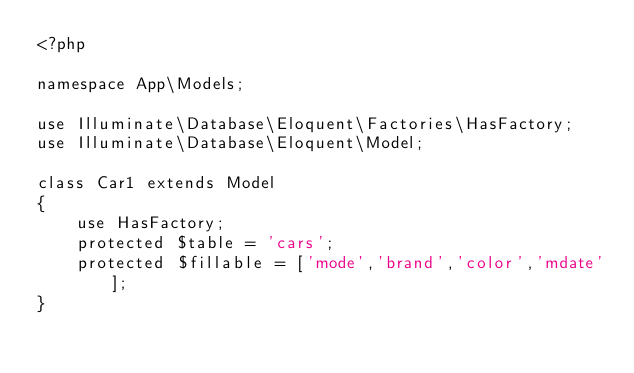<code> <loc_0><loc_0><loc_500><loc_500><_PHP_><?php

namespace App\Models;

use Illuminate\Database\Eloquent\Factories\HasFactory;
use Illuminate\Database\Eloquent\Model;

class Car1 extends Model
{
    use HasFactory;
    protected $table = 'cars';
    protected $fillable = ['mode','brand','color','mdate'];
}
</code> 